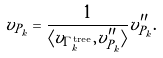Convert formula to latex. <formula><loc_0><loc_0><loc_500><loc_500>v _ { P _ { k } } = \frac { 1 } { \langle v _ { \Gamma ^ { \text {tree} } _ { k } } , v ^ { \prime \prime } _ { P _ { k } } \rangle } v ^ { \prime \prime } _ { P _ { k } } .</formula> 